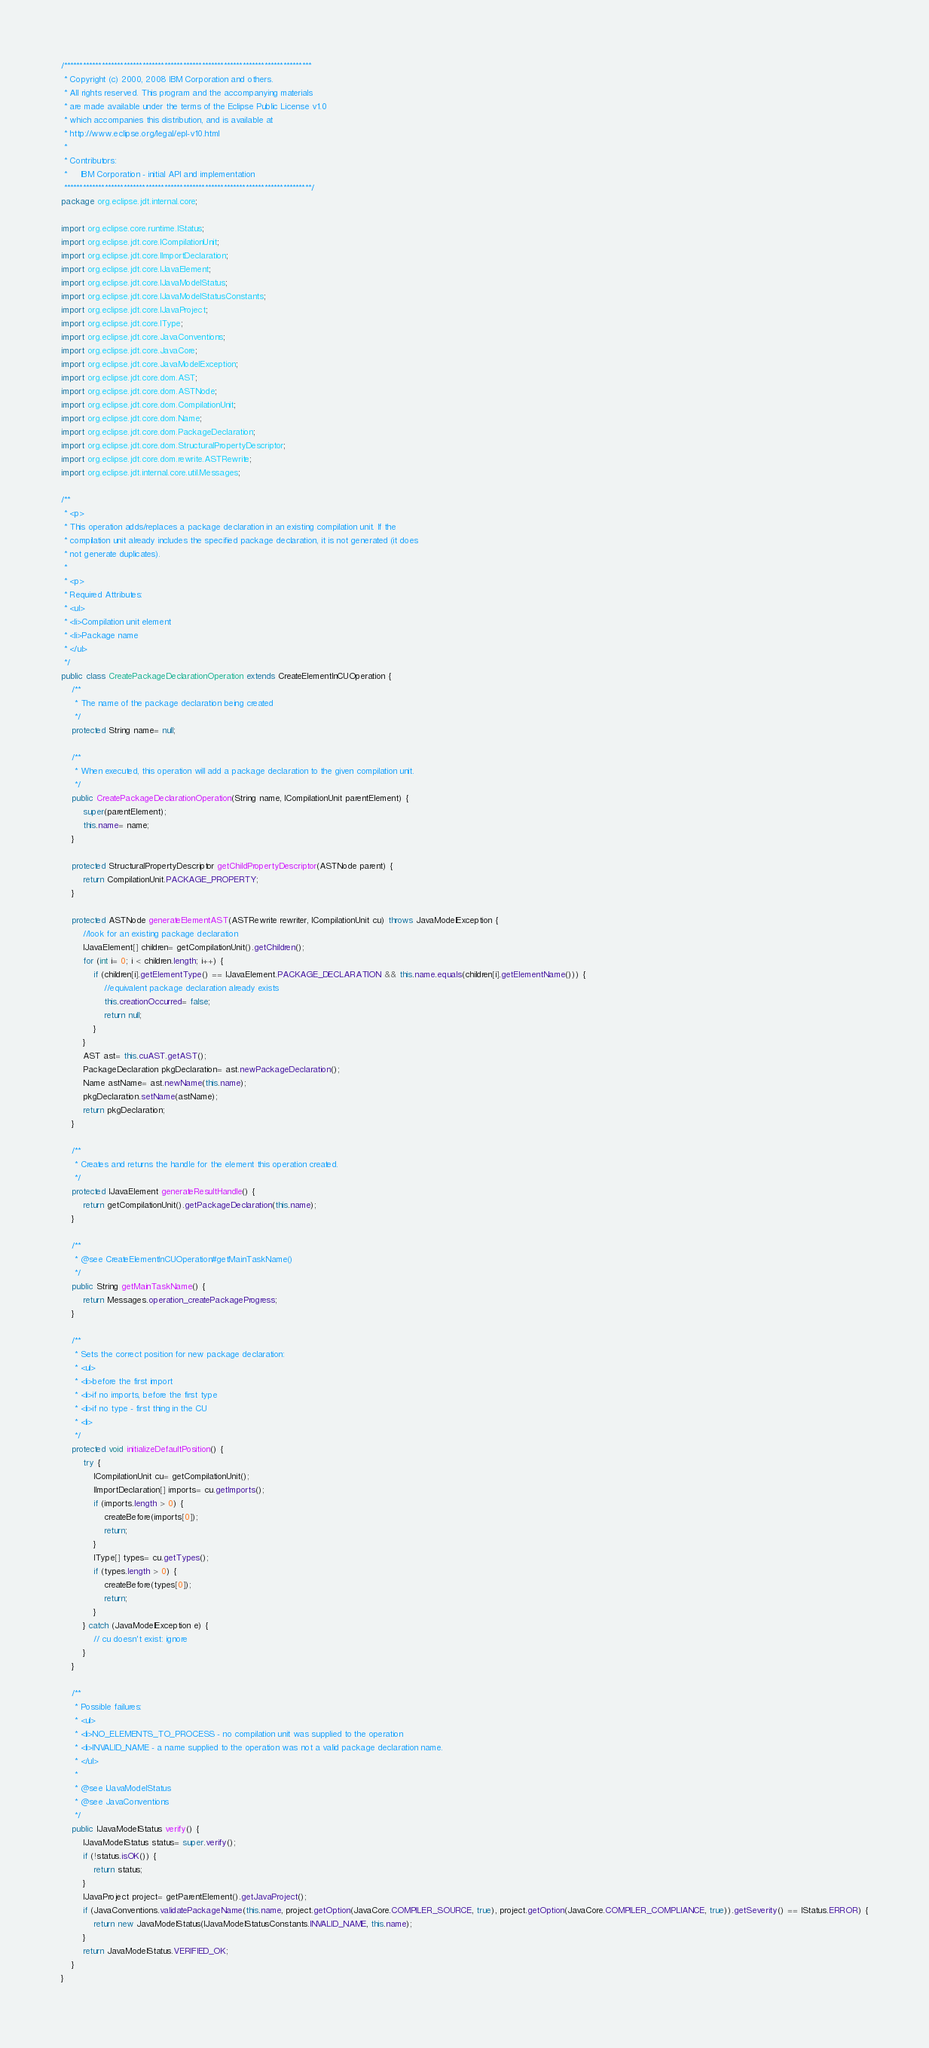Convert code to text. <code><loc_0><loc_0><loc_500><loc_500><_Java_>/*******************************************************************************
 * Copyright (c) 2000, 2008 IBM Corporation and others.
 * All rights reserved. This program and the accompanying materials
 * are made available under the terms of the Eclipse Public License v1.0
 * which accompanies this distribution, and is available at
 * http://www.eclipse.org/legal/epl-v10.html
 *
 * Contributors:
 *     IBM Corporation - initial API and implementation
 *******************************************************************************/
package org.eclipse.jdt.internal.core;

import org.eclipse.core.runtime.IStatus;
import org.eclipse.jdt.core.ICompilationUnit;
import org.eclipse.jdt.core.IImportDeclaration;
import org.eclipse.jdt.core.IJavaElement;
import org.eclipse.jdt.core.IJavaModelStatus;
import org.eclipse.jdt.core.IJavaModelStatusConstants;
import org.eclipse.jdt.core.IJavaProject;
import org.eclipse.jdt.core.IType;
import org.eclipse.jdt.core.JavaConventions;
import org.eclipse.jdt.core.JavaCore;
import org.eclipse.jdt.core.JavaModelException;
import org.eclipse.jdt.core.dom.AST;
import org.eclipse.jdt.core.dom.ASTNode;
import org.eclipse.jdt.core.dom.CompilationUnit;
import org.eclipse.jdt.core.dom.Name;
import org.eclipse.jdt.core.dom.PackageDeclaration;
import org.eclipse.jdt.core.dom.StructuralPropertyDescriptor;
import org.eclipse.jdt.core.dom.rewrite.ASTRewrite;
import org.eclipse.jdt.internal.core.util.Messages;

/**
 * <p>
 * This operation adds/replaces a package declaration in an existing compilation unit. If the
 * compilation unit already includes the specified package declaration, it is not generated (it does
 * not generate duplicates).
 * 
 * <p>
 * Required Attributes:
 * <ul>
 * <li>Compilation unit element
 * <li>Package name
 * </ul>
 */
public class CreatePackageDeclarationOperation extends CreateElementInCUOperation {
	/**
	 * The name of the package declaration being created
	 */
	protected String name= null;

	/**
	 * When executed, this operation will add a package declaration to the given compilation unit.
	 */
	public CreatePackageDeclarationOperation(String name, ICompilationUnit parentElement) {
		super(parentElement);
		this.name= name;
	}

	protected StructuralPropertyDescriptor getChildPropertyDescriptor(ASTNode parent) {
		return CompilationUnit.PACKAGE_PROPERTY;
	}

	protected ASTNode generateElementAST(ASTRewrite rewriter, ICompilationUnit cu) throws JavaModelException {
		//look for an existing package declaration
		IJavaElement[] children= getCompilationUnit().getChildren();
		for (int i= 0; i < children.length; i++) {
			if (children[i].getElementType() == IJavaElement.PACKAGE_DECLARATION && this.name.equals(children[i].getElementName())) {
				//equivalent package declaration already exists
				this.creationOccurred= false;
				return null;
			}
		}
		AST ast= this.cuAST.getAST();
		PackageDeclaration pkgDeclaration= ast.newPackageDeclaration();
		Name astName= ast.newName(this.name);
		pkgDeclaration.setName(astName);
		return pkgDeclaration;
	}

	/**
	 * Creates and returns the handle for the element this operation created.
	 */
	protected IJavaElement generateResultHandle() {
		return getCompilationUnit().getPackageDeclaration(this.name);
	}

	/**
	 * @see CreateElementInCUOperation#getMainTaskName()
	 */
	public String getMainTaskName() {
		return Messages.operation_createPackageProgress;
	}

	/**
	 * Sets the correct position for new package declaration:
	 * <ul>
	 * <li>before the first import
	 * <li>if no imports, before the first type
	 * <li>if no type - first thing in the CU
	 * <li>
	 */
	protected void initializeDefaultPosition() {
		try {
			ICompilationUnit cu= getCompilationUnit();
			IImportDeclaration[] imports= cu.getImports();
			if (imports.length > 0) {
				createBefore(imports[0]);
				return;
			}
			IType[] types= cu.getTypes();
			if (types.length > 0) {
				createBefore(types[0]);
				return;
			}
		} catch (JavaModelException e) {
			// cu doesn't exist: ignore
		}
	}

	/**
	 * Possible failures:
	 * <ul>
	 * <li>NO_ELEMENTS_TO_PROCESS - no compilation unit was supplied to the operation
	 * <li>INVALID_NAME - a name supplied to the operation was not a valid package declaration name.
	 * </ul>
	 * 
	 * @see IJavaModelStatus
	 * @see JavaConventions
	 */
	public IJavaModelStatus verify() {
		IJavaModelStatus status= super.verify();
		if (!status.isOK()) {
			return status;
		}
		IJavaProject project= getParentElement().getJavaProject();
		if (JavaConventions.validatePackageName(this.name, project.getOption(JavaCore.COMPILER_SOURCE, true), project.getOption(JavaCore.COMPILER_COMPLIANCE, true)).getSeverity() == IStatus.ERROR) {
			return new JavaModelStatus(IJavaModelStatusConstants.INVALID_NAME, this.name);
		}
		return JavaModelStatus.VERIFIED_OK;
	}
}
</code> 